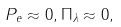Convert formula to latex. <formula><loc_0><loc_0><loc_500><loc_500>P _ { e } \approx 0 , \Pi _ { \lambda } \approx 0 ,</formula> 